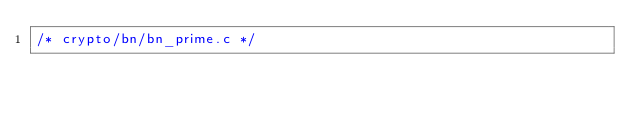Convert code to text. <code><loc_0><loc_0><loc_500><loc_500><_C_>/* crypto/bn/bn_prime.c */</code> 